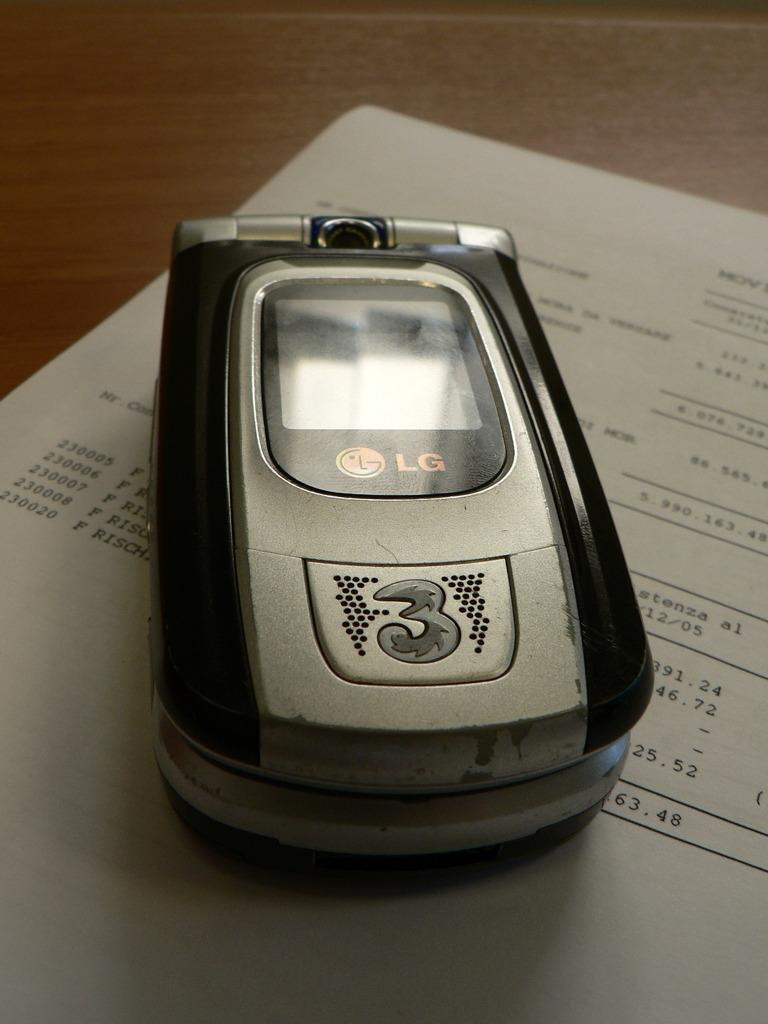What electronic device is present in the image? There is a mobile phone in the image. Where is the mobile phone placed? The mobile phone is on a piece of paper. What type of ring is the mobile phone wearing in the image? There is no ring present in the image, nor is the mobile phone wearing any jewelry. 